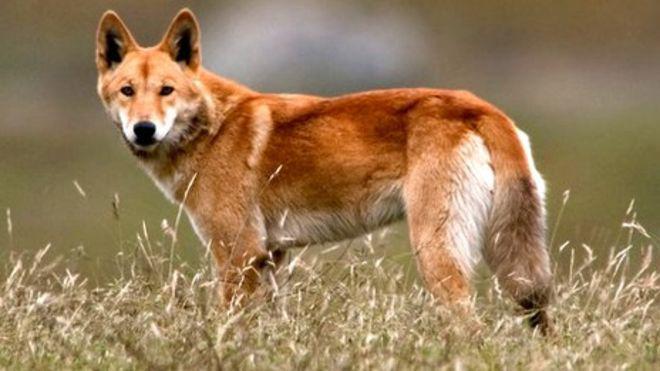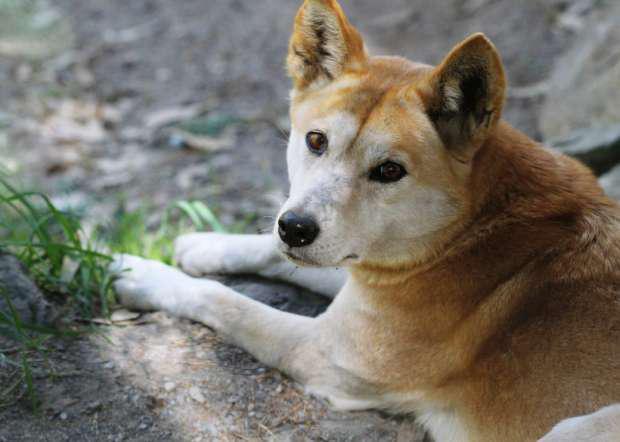The first image is the image on the left, the second image is the image on the right. Examine the images to the left and right. Is the description "In the left image, a lone dog stands up, and is looking right at the camera." accurate? Answer yes or no. Yes. The first image is the image on the left, the second image is the image on the right. Examine the images to the left and right. Is the description "There is a single tan and white canine facing left standing on the tan and green grass." accurate? Answer yes or no. Yes. 